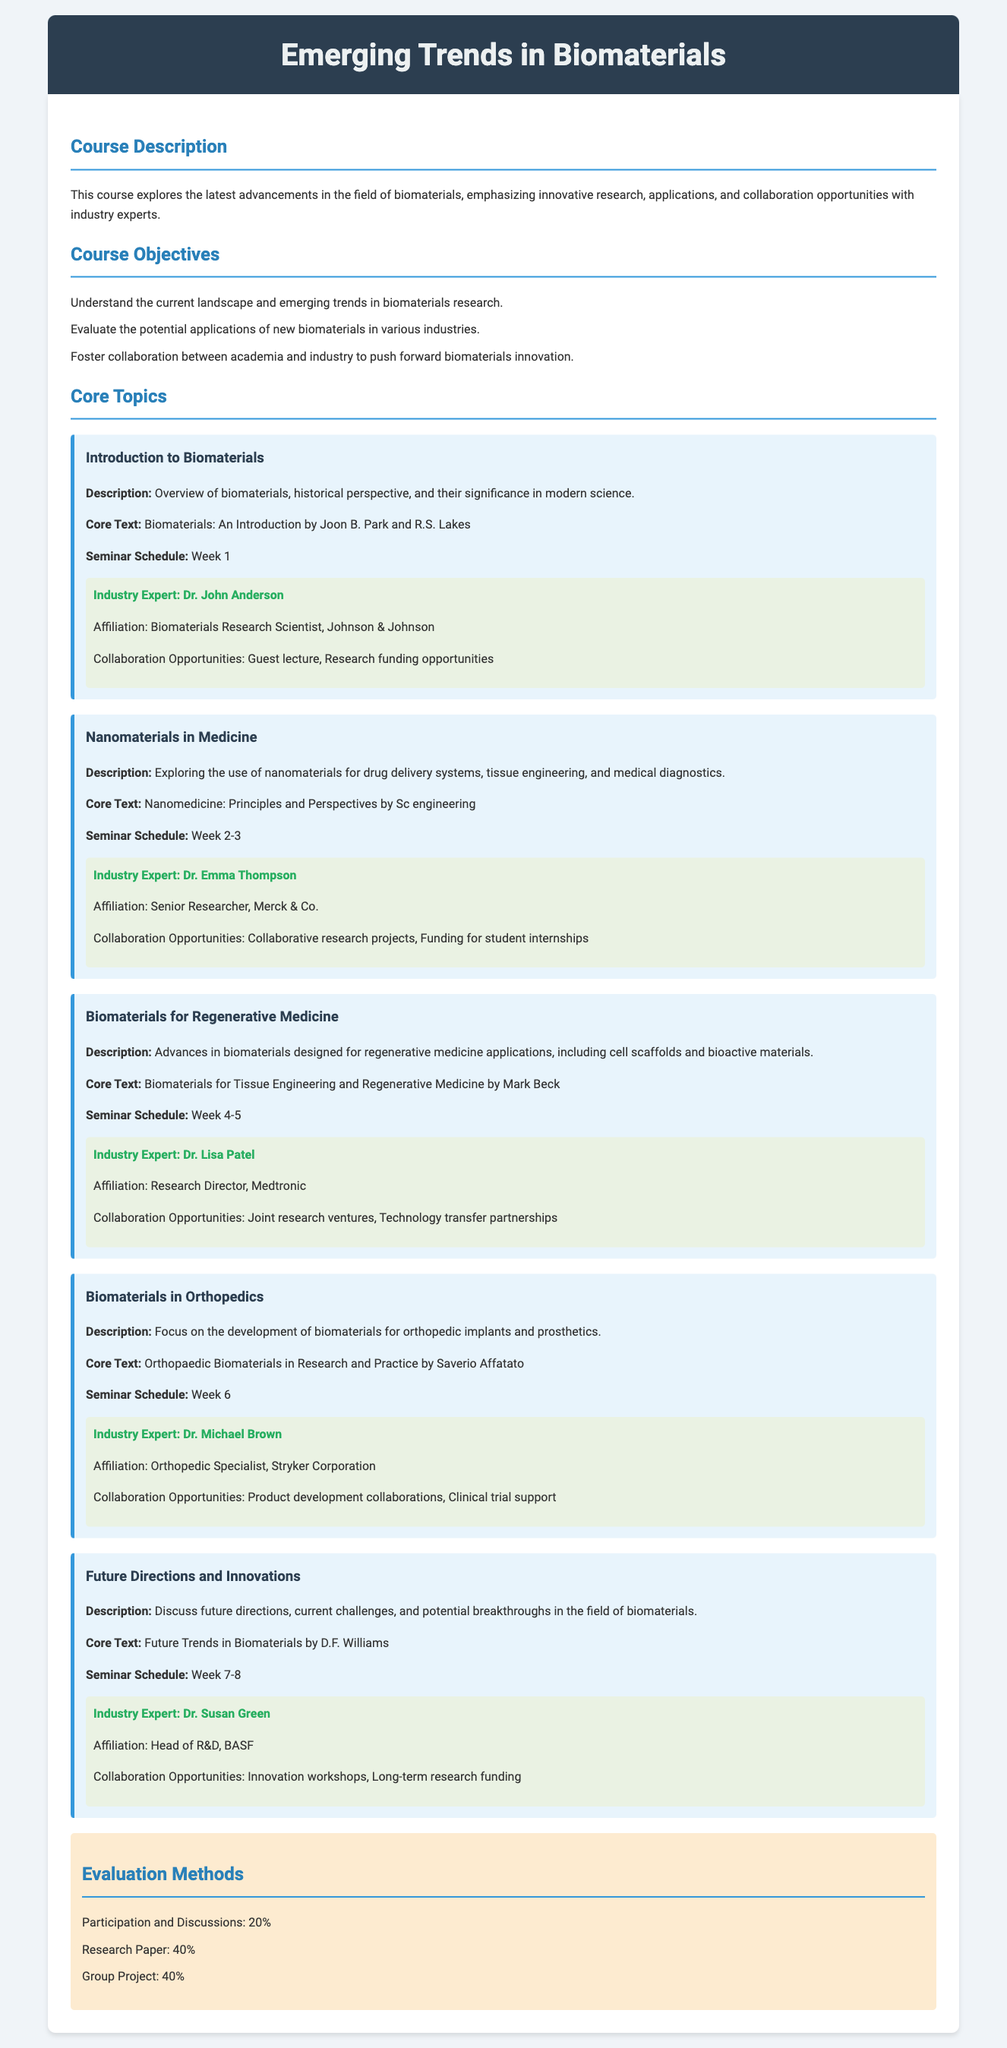What is the course title? The course title is stated at the beginning of the document under the header.
Answer: Emerging Trends in Biomaterials Who is the industry expert for Week 1? The name of the industry expert for Week 1 is mentioned in the seminar schedule.
Answer: Dr. John Anderson What is the seminar schedule for Nanomaterials in Medicine? The seminar schedule is provided underneath the description of the topic in the document.
Answer: Week 2-3 What is the core text for Biomaterials for Regenerative Medicine? The core text is listed within the topic description for that specific subject.
Answer: Biomaterials for Tissue Engineering and Regenerative Medicine by Mark Beck What percentage of the evaluation is based on the research paper? The percentage is given in the evaluation methods section of the syllabus.
Answer: 40% Which industry expert is affiliated with Merck & Co.? The document specifies the expert's affiliation in the description of the nanomaterials topic.
Answer: Dr. Emma Thompson What is the focus of the topic on Week 6? The topic description outlines the specific area of focus discussed in the course.
Answer: Development of biomaterials for orthopedic implants and prosthetics What is the total percentage of participation and discussions in the evaluation? The document lists the contributions of different evaluation components in the syllabus.
Answer: 20% 